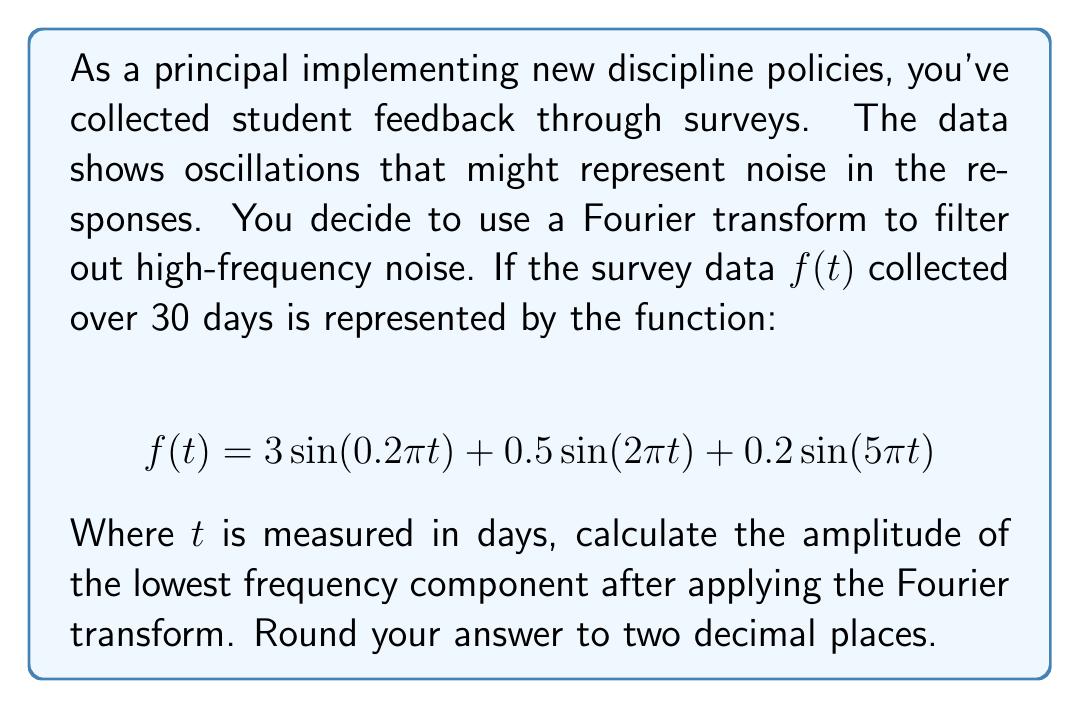Could you help me with this problem? To solve this problem, we'll follow these steps:

1) First, recall that the Fourier transform of a sine function is given by:

   $$\mathcal{F}\{A\sin(2\pi ft)\} = \frac{iA}{2}[\delta(F+f) - \delta(F-f)]$$

   Where $A$ is the amplitude, $f$ is the frequency, and $\delta$ is the Dirac delta function.

2) In our function $f(t)$, we have three sine components:

   a) $3\sin(0.2\pi t)$ with $A_1=3$, $f_1=0.1$
   b) $0.5\sin(2\pi t)$ with $A_2=0.5$, $f_2=1$
   c) $0.2\sin(5\pi t)$ with $A_3=0.2$, $f_3=2.5$

3) The Fourier transform of $f(t)$ will be the sum of the Fourier transforms of these components:

   $$\mathcal{F}\{f(t)\} = \frac{3i}{2}[\delta(F+0.1) - \delta(F-0.1)] + \frac{0.5i}{2}[\delta(F+1) - \delta(F-1)] + \frac{0.2i}{2}[\delta(F+2.5) - \delta(F-2.5)]$$

4) The amplitude of each component in the frequency domain is half of its amplitude in the time domain.

5) The lowest frequency component corresponds to $f_1=0.1$, which had an amplitude of 3 in the time domain.

6) Therefore, the amplitude of this component in the frequency domain is $3/2 = 1.5$.
Answer: $1.50$ 